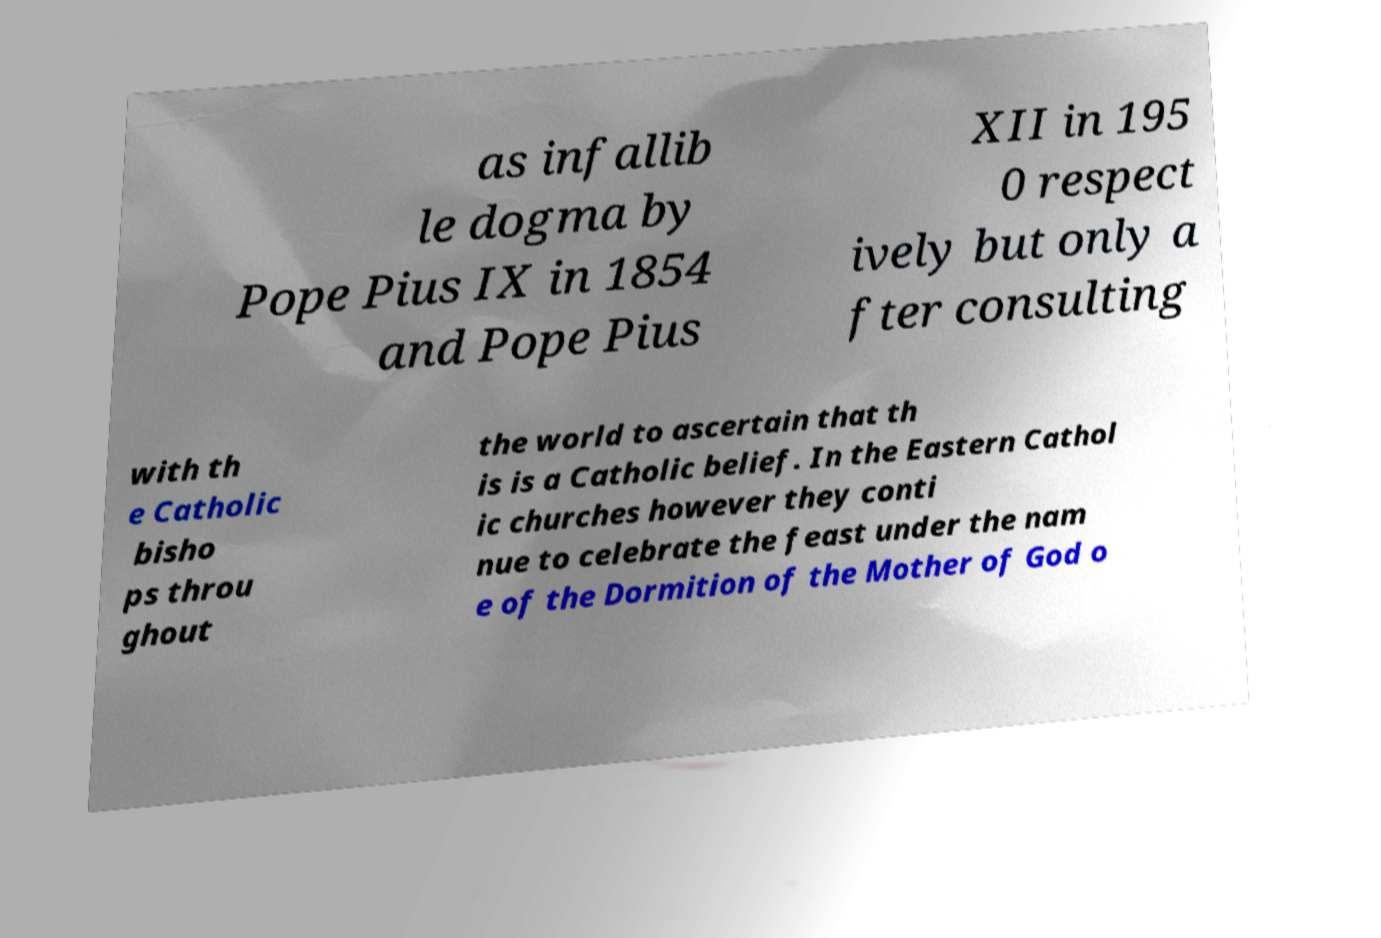Can you read and provide the text displayed in the image?This photo seems to have some interesting text. Can you extract and type it out for me? as infallib le dogma by Pope Pius IX in 1854 and Pope Pius XII in 195 0 respect ively but only a fter consulting with th e Catholic bisho ps throu ghout the world to ascertain that th is is a Catholic belief. In the Eastern Cathol ic churches however they conti nue to celebrate the feast under the nam e of the Dormition of the Mother of God o 